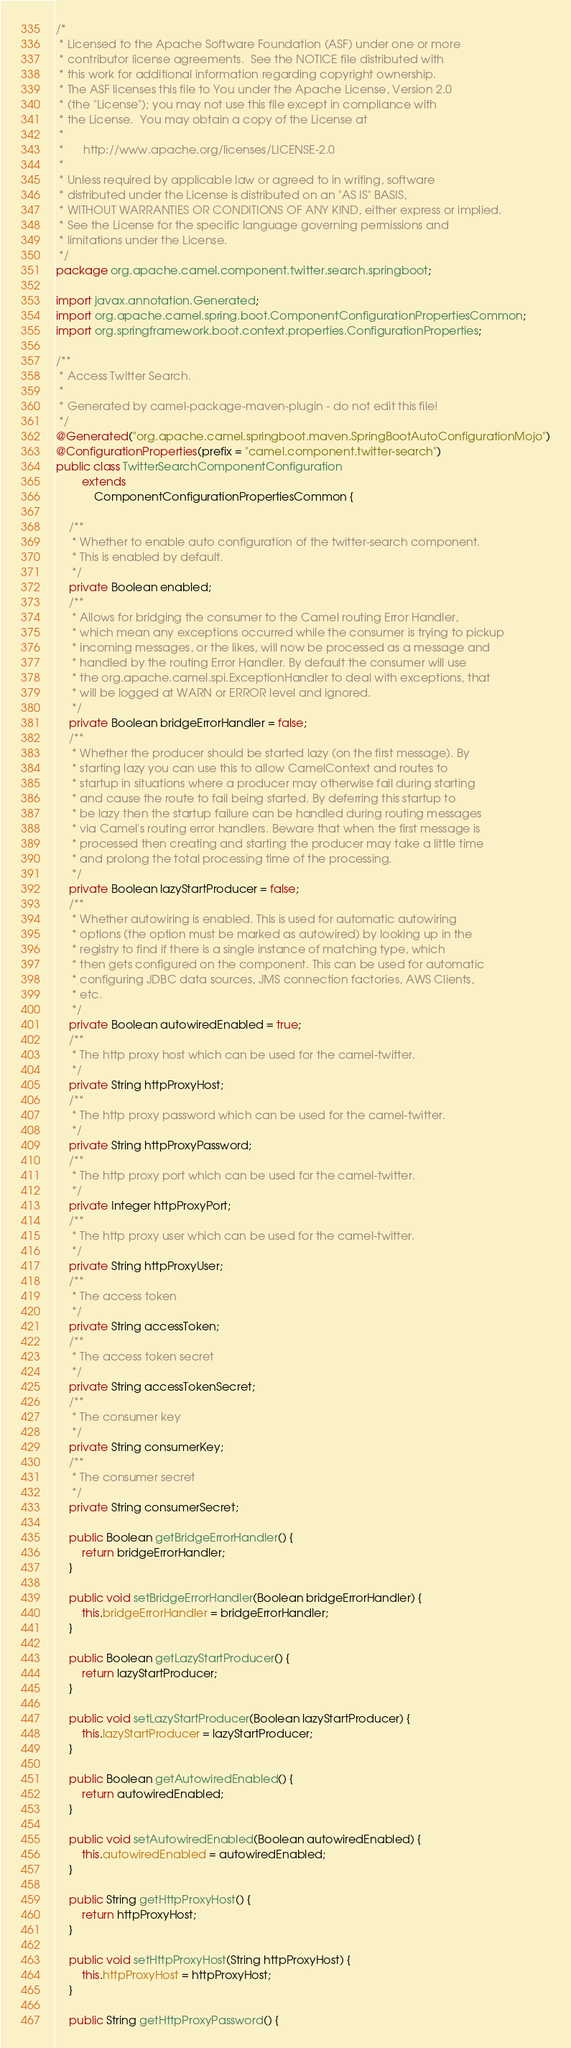Convert code to text. <code><loc_0><loc_0><loc_500><loc_500><_Java_>/*
 * Licensed to the Apache Software Foundation (ASF) under one or more
 * contributor license agreements.  See the NOTICE file distributed with
 * this work for additional information regarding copyright ownership.
 * The ASF licenses this file to You under the Apache License, Version 2.0
 * (the "License"); you may not use this file except in compliance with
 * the License.  You may obtain a copy of the License at
 *
 *      http://www.apache.org/licenses/LICENSE-2.0
 *
 * Unless required by applicable law or agreed to in writing, software
 * distributed under the License is distributed on an "AS IS" BASIS,
 * WITHOUT WARRANTIES OR CONDITIONS OF ANY KIND, either express or implied.
 * See the License for the specific language governing permissions and
 * limitations under the License.
 */
package org.apache.camel.component.twitter.search.springboot;

import javax.annotation.Generated;
import org.apache.camel.spring.boot.ComponentConfigurationPropertiesCommon;
import org.springframework.boot.context.properties.ConfigurationProperties;

/**
 * Access Twitter Search.
 * 
 * Generated by camel-package-maven-plugin - do not edit this file!
 */
@Generated("org.apache.camel.springboot.maven.SpringBootAutoConfigurationMojo")
@ConfigurationProperties(prefix = "camel.component.twitter-search")
public class TwitterSearchComponentConfiguration
        extends
            ComponentConfigurationPropertiesCommon {

    /**
     * Whether to enable auto configuration of the twitter-search component.
     * This is enabled by default.
     */
    private Boolean enabled;
    /**
     * Allows for bridging the consumer to the Camel routing Error Handler,
     * which mean any exceptions occurred while the consumer is trying to pickup
     * incoming messages, or the likes, will now be processed as a message and
     * handled by the routing Error Handler. By default the consumer will use
     * the org.apache.camel.spi.ExceptionHandler to deal with exceptions, that
     * will be logged at WARN or ERROR level and ignored.
     */
    private Boolean bridgeErrorHandler = false;
    /**
     * Whether the producer should be started lazy (on the first message). By
     * starting lazy you can use this to allow CamelContext and routes to
     * startup in situations where a producer may otherwise fail during starting
     * and cause the route to fail being started. By deferring this startup to
     * be lazy then the startup failure can be handled during routing messages
     * via Camel's routing error handlers. Beware that when the first message is
     * processed then creating and starting the producer may take a little time
     * and prolong the total processing time of the processing.
     */
    private Boolean lazyStartProducer = false;
    /**
     * Whether autowiring is enabled. This is used for automatic autowiring
     * options (the option must be marked as autowired) by looking up in the
     * registry to find if there is a single instance of matching type, which
     * then gets configured on the component. This can be used for automatic
     * configuring JDBC data sources, JMS connection factories, AWS Clients,
     * etc.
     */
    private Boolean autowiredEnabled = true;
    /**
     * The http proxy host which can be used for the camel-twitter.
     */
    private String httpProxyHost;
    /**
     * The http proxy password which can be used for the camel-twitter.
     */
    private String httpProxyPassword;
    /**
     * The http proxy port which can be used for the camel-twitter.
     */
    private Integer httpProxyPort;
    /**
     * The http proxy user which can be used for the camel-twitter.
     */
    private String httpProxyUser;
    /**
     * The access token
     */
    private String accessToken;
    /**
     * The access token secret
     */
    private String accessTokenSecret;
    /**
     * The consumer key
     */
    private String consumerKey;
    /**
     * The consumer secret
     */
    private String consumerSecret;

    public Boolean getBridgeErrorHandler() {
        return bridgeErrorHandler;
    }

    public void setBridgeErrorHandler(Boolean bridgeErrorHandler) {
        this.bridgeErrorHandler = bridgeErrorHandler;
    }

    public Boolean getLazyStartProducer() {
        return lazyStartProducer;
    }

    public void setLazyStartProducer(Boolean lazyStartProducer) {
        this.lazyStartProducer = lazyStartProducer;
    }

    public Boolean getAutowiredEnabled() {
        return autowiredEnabled;
    }

    public void setAutowiredEnabled(Boolean autowiredEnabled) {
        this.autowiredEnabled = autowiredEnabled;
    }

    public String getHttpProxyHost() {
        return httpProxyHost;
    }

    public void setHttpProxyHost(String httpProxyHost) {
        this.httpProxyHost = httpProxyHost;
    }

    public String getHttpProxyPassword() {</code> 